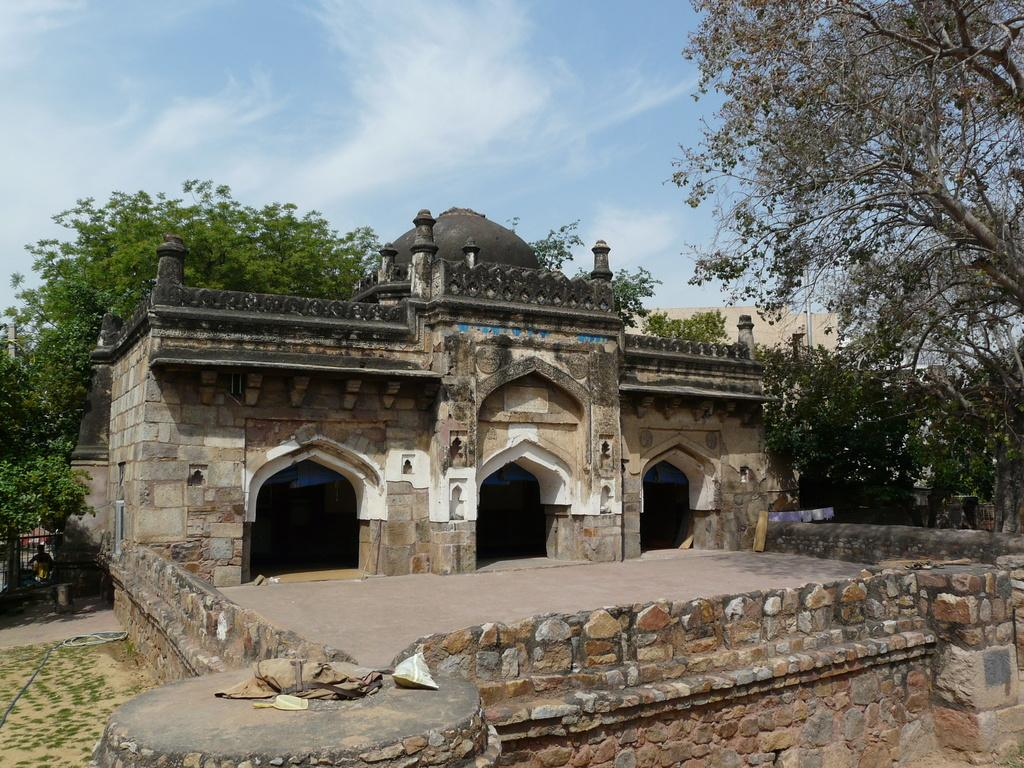What is the main structure in the center of the image? There is a fort in the center of the image. What can be seen in the background of the image? There are trees and the sky visible in the background of the image. What is located at the bottom of the image? There is a wall at the bottom of the image. Where is the gate located in the image? The gate is on the left side of the image. What type of songs can be heard coming from the fort in the image? There is no indication in the image that songs are being played or heard, so it's not possible to determine what songs might be present. 